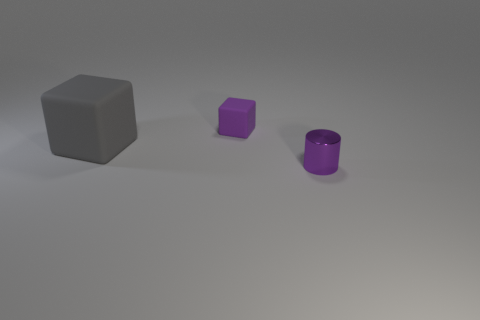Is the tiny cylinder made of the same material as the block behind the gray matte thing?
Your response must be concise. No. Are there any cylinders that have the same size as the metallic object?
Provide a succinct answer. No. Is the number of large gray rubber blocks that are right of the purple cylinder the same as the number of large purple matte objects?
Offer a terse response. Yes. What size is the gray cube?
Offer a terse response. Large. How many small purple objects are right of the tiny purple thing behind the large gray cube?
Offer a very short reply. 1. There is a thing that is both in front of the small purple matte thing and behind the purple shiny object; what is its shape?
Offer a terse response. Cube. How many other things have the same color as the shiny object?
Keep it short and to the point. 1. There is a rubber cube in front of the purple thing behind the gray cube; are there any large things that are behind it?
Give a very brief answer. No. What size is the thing that is to the right of the gray object and behind the shiny object?
Give a very brief answer. Small. How many small things are the same material as the large gray block?
Ensure brevity in your answer.  1. 